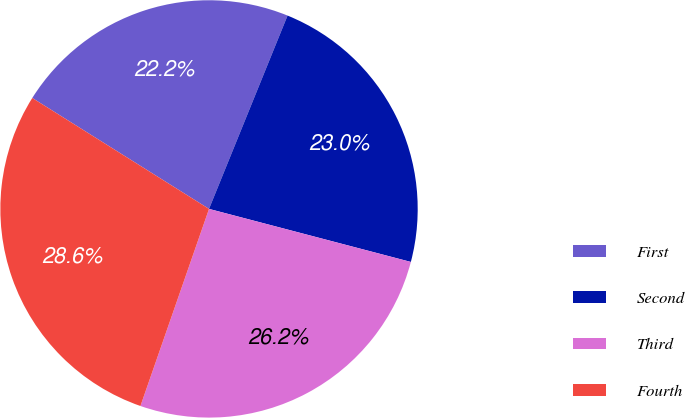Convert chart. <chart><loc_0><loc_0><loc_500><loc_500><pie_chart><fcel>First<fcel>Second<fcel>Third<fcel>Fourth<nl><fcel>22.22%<fcel>22.95%<fcel>26.24%<fcel>28.59%<nl></chart> 